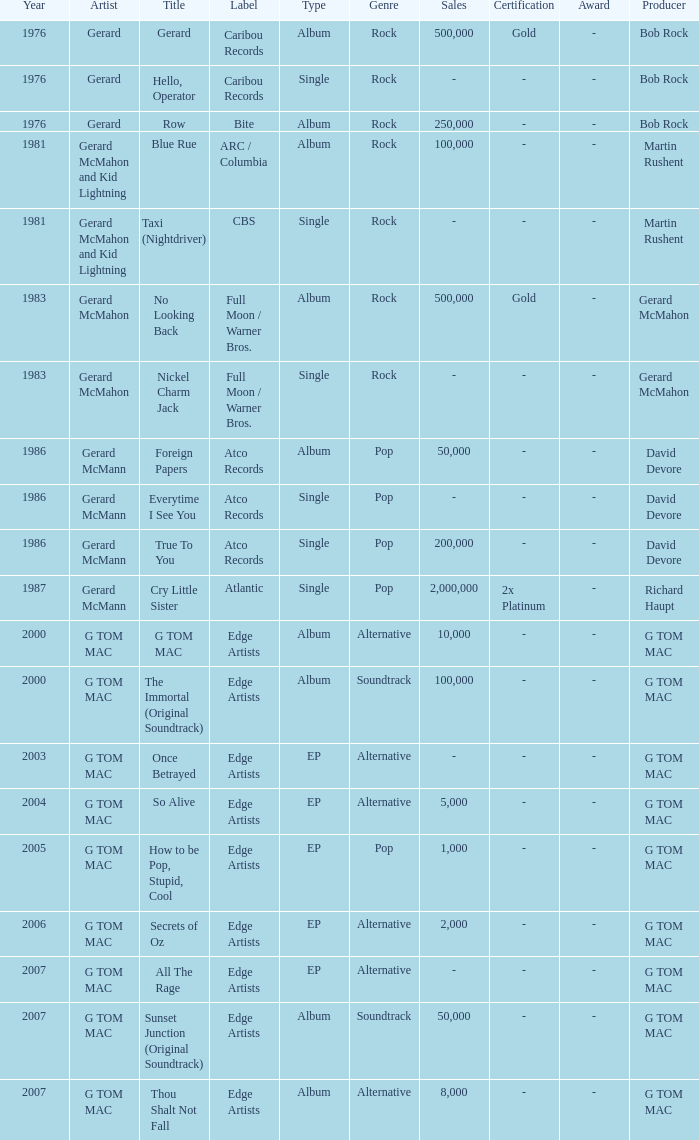Which Title has a Type of ep and a Year larger than 2003? So Alive, How to be Pop, Stupid, Cool, Secrets of Oz, All The Rage. 